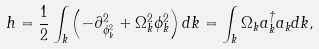Convert formula to latex. <formula><loc_0><loc_0><loc_500><loc_500>h = \frac { 1 } { 2 } \int _ { k } \left ( - \partial _ { \phi _ { k } ^ { 2 } } ^ { 2 } + \Omega _ { k } ^ { 2 } \phi _ { k } ^ { 2 } \right ) d k = \int _ { k } \Omega _ { k } a _ { k } ^ { \dagger } a _ { k } d k ,</formula> 